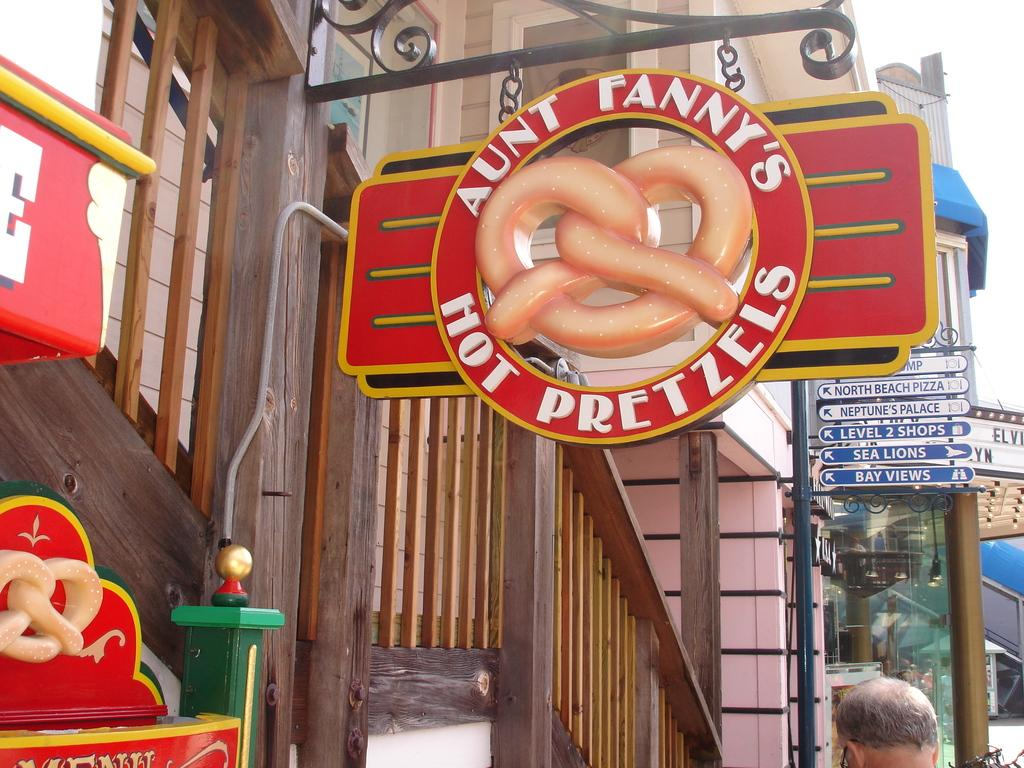What can be seen in the foreground of the picture? In the foreground of the picture, there are hoardings, railing, a staircase, and buildings. Are there any people visible in the picture? Yes, there is a person's head at the bottom of the picture. What else can be seen at the bottom of the picture? There are bicycles at the bottom of the picture. What is the lighting condition on the right side of the picture? There is sunlight on the right side of the picture. Can you tell me what type of offer is being made by the bushes in the picture? There are no bushes present in the picture; the image features hoardings, railing, a staircase, buildings, a person's head, bicycles, and sunlight. How many lakes can be seen in the picture? There are no lakes present in the picture. 